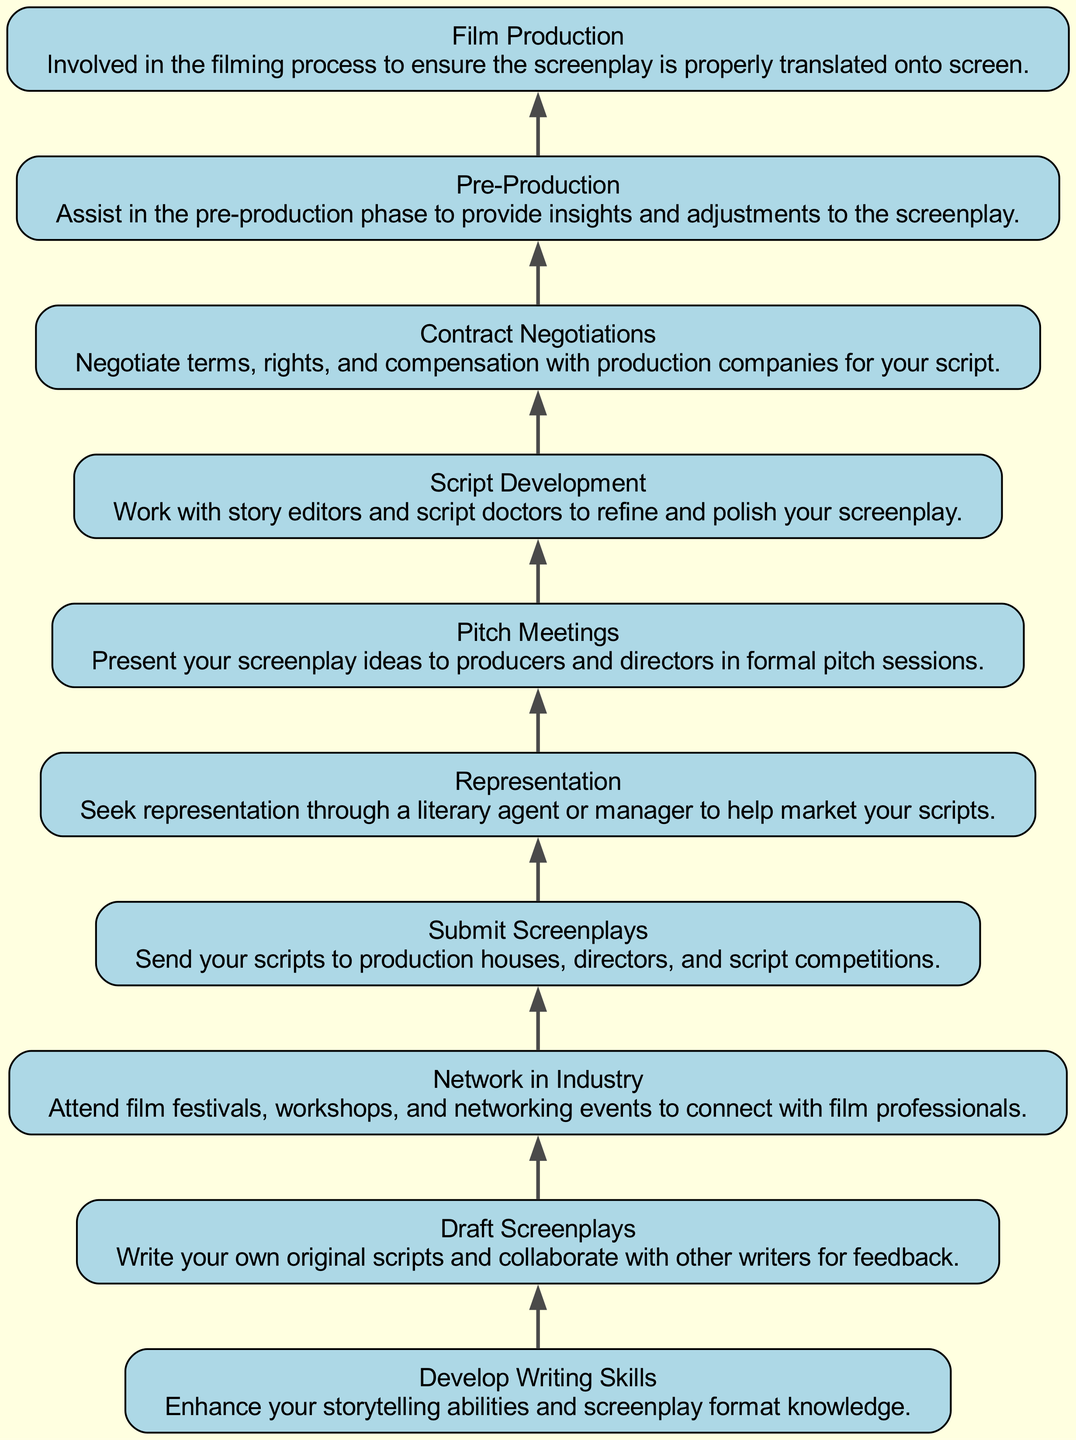What is the starting point of the diagram? The starting point of the diagram is "Develop Writing Skills," which appears at the bottom of the flow chart. This node initiates the process described in the diagram.
Answer: Develop Writing Skills How many nodes are in the diagram? The diagram consists of ten distinct nodes, each representing a different stage or action within the process of navigating the Indian film industry as a screenwriter.
Answer: 10 What is the final step in the process? The final step in the process, as per the flow chart, is "Film Production." This indicates the ultimate stage where the screenplay is brought to life through filming.
Answer: Film Production Which node comes directly after 'Submit Screenplays'? The node that follows 'Submit Screenplays' is 'Representation.' This indicates a direct progression from submitting scripts to seeking representation in the industry.
Answer: Representation What is the relationship between 'Pitch Meetings' and 'Script Development'? 'Script Development' comes after 'Pitch Meetings,' indicating that after ideas are pitched, further work is needed to refine the screenplay. This shows a sequential relationship between pitching ideas and developing scripts.
Answer: 'Script Development' follows 'Pitch Meetings' What are the two processes that take place after 'Draft Screenplays'? After 'Draft Screenplays,' the two processes that follow are 'Network in Industry' and 'Submit Screenplays.' This bifurcation suggests that writers can either focus on networking or submit their scripts.
Answer: Network in Industry, Submit Screenplays How does 'Contract Negotiations' relate to 'Pre-Production'? 'Contract Negotiations' comes before 'Pre-Production.' This indicates that negotiations regarding terms and rights occur prior to the pre-production phase of filmmaking.
Answer: 'Contract Negotiations' precedes 'Pre-Production' Which node contains information about working with story editors? The node that contains information about collaborating with story editors is 'Script Development.' It emphasizes the importance of refining the screenplay during this stage.
Answer: Script Development What is the purpose of 'Film Production' in the flow chart? The purpose of 'Film Production' is to ensure that the screenplay is accurately translated into a visual format. This step marks the realization of the script's vision on screen.
Answer: Ensure screenplay realization 